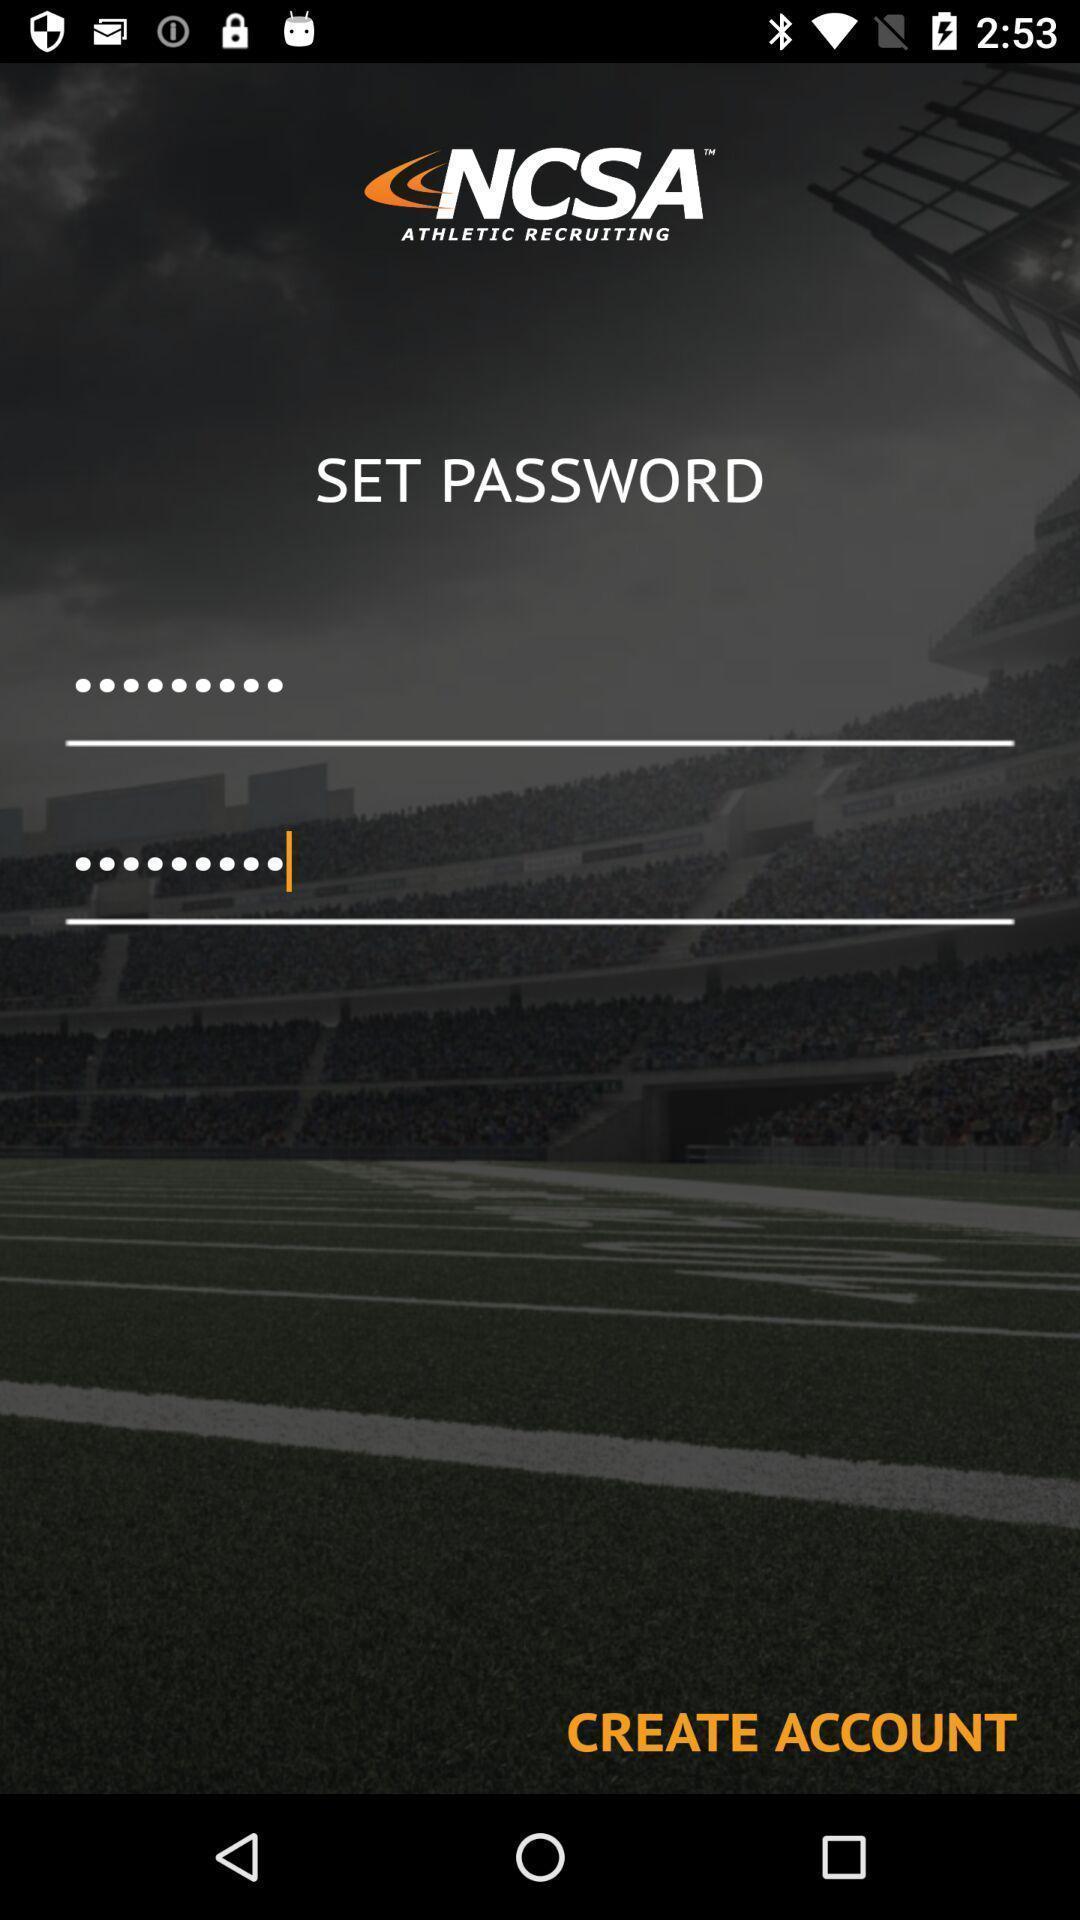Provide a detailed account of this screenshot. Welcome page showing information to create account. 